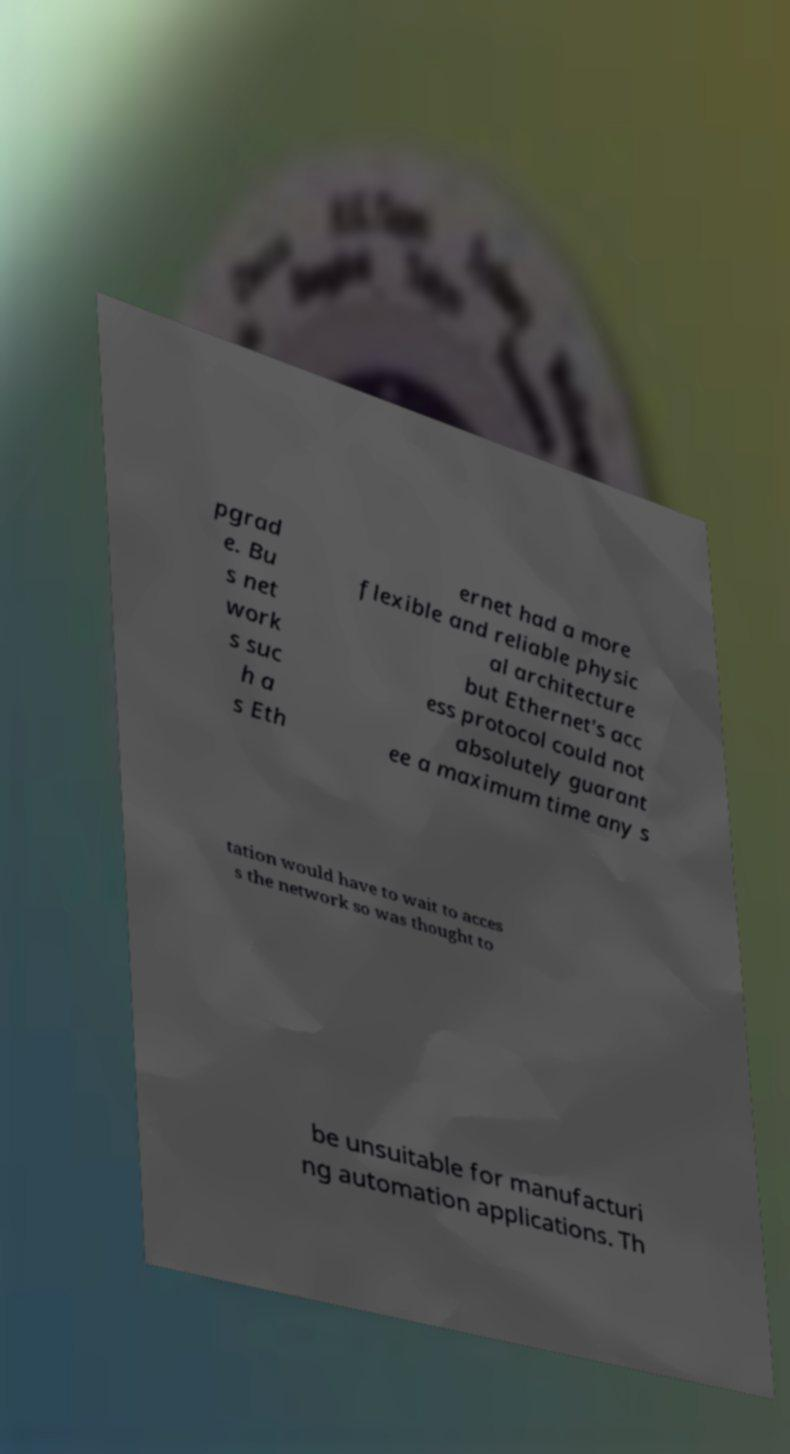Please read and relay the text visible in this image. What does it say? pgrad e. Bu s net work s suc h a s Eth ernet had a more flexible and reliable physic al architecture but Ethernet's acc ess protocol could not absolutely guarant ee a maximum time any s tation would have to wait to acces s the network so was thought to be unsuitable for manufacturi ng automation applications. Th 